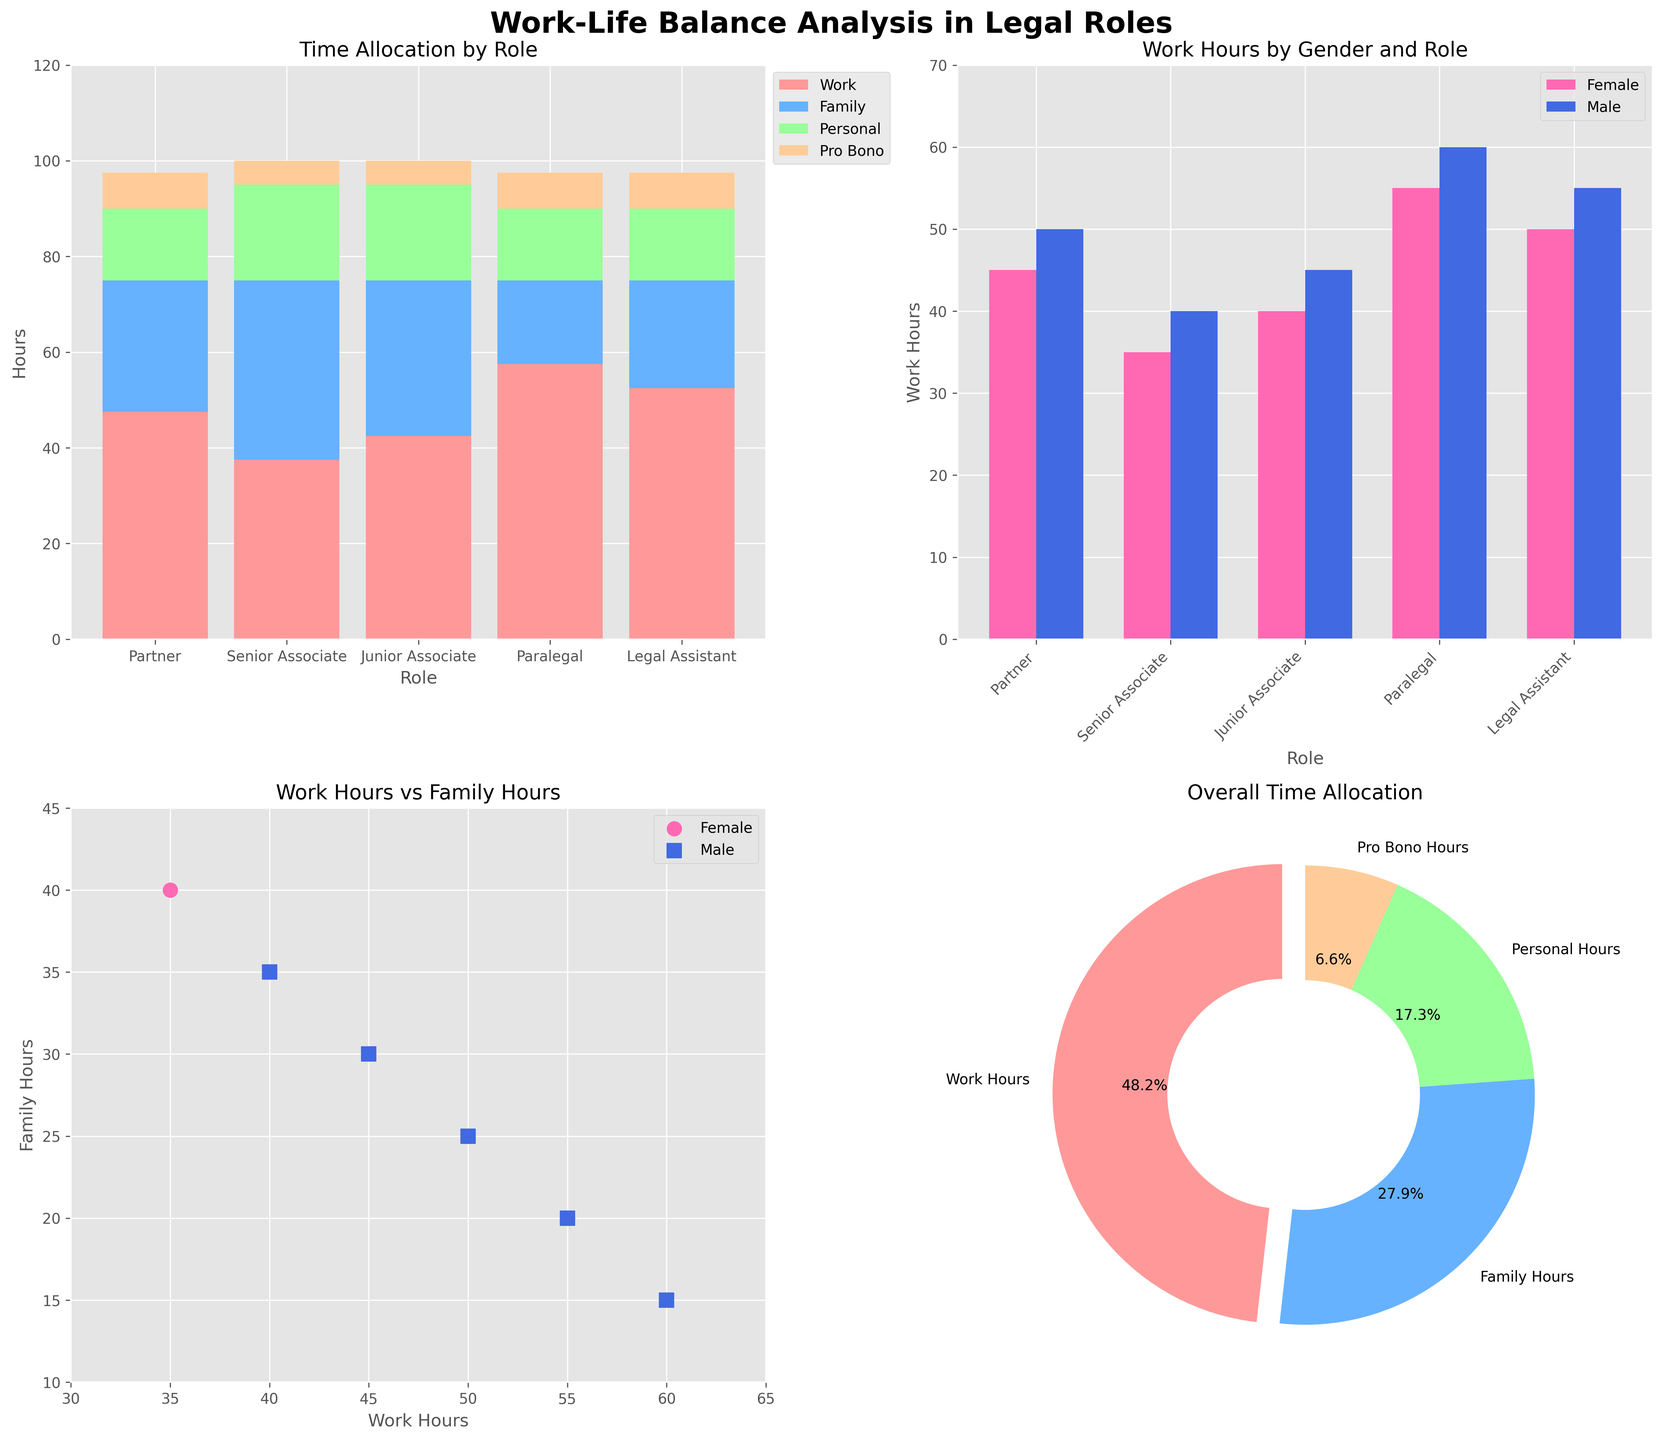what does the first subplot (top-left) represent? The first subplot (top-left) is a stacked bar chart that shows the allocation of different types of hours (work, family, personal, pro bono) for various legal roles. Each bar represents a role, and segments within each bar represent different hour types.
Answer: Time allocation by role Which role allocates the most hours to work in the first subplot? By examining the highest segment for work hours in the stacked bar chart, we see the Partner role has the highest work hours among all roles.
Answer: Partner How many more hours do male Senior Associates work compared to female Senior Associates in the second subplot? In the grouped bar chart (second subplot), the male Senior Associate bar is at 55 hours and the female Senior Associate bar is at 50 hours. The difference is 55 - 50 hours.
Answer: 5 hours Which role spends the least amount of time on personal hours according to the first subplot? According to the first subplot, the Partner role has the smallest segment of the bar for personal hours.
Answer: Partner In the scatter plot (subplot three), what is the relationship between work hours and family hours for males? In the third subplot, the scatter plot shows that as work hours increase, family hours decrease slightly for males, as indicated by the downward trend for the blue square markers.
Answer: Negative correlation What is the total number of hours allocated by Paralegals according to the first subplot? In the first subplot, Paralegals allocate 40 hours to work, 35 hours to family, 20 hours to personal, and 5 hours to pro bono. Adding these gives 40 + 35 + 20 + 5 = 100 hours.
Answer: 100 hours According to the pie chart (subplot four), what percentage of total time is allocated to work hours? The pie chart shows the overall time allocation across all roles and genders. Work Hours segment is visually the largest, representing 55.5%.
Answer: 55.5% Who spends more hours on family time, junior associates or senior associates? In the first subplot, Junior Associates spend more time on family (30 hours for females, 25 for males) compared to Senior Associates (25 hours for females, 20 for males).
Answer: Junior Associates 